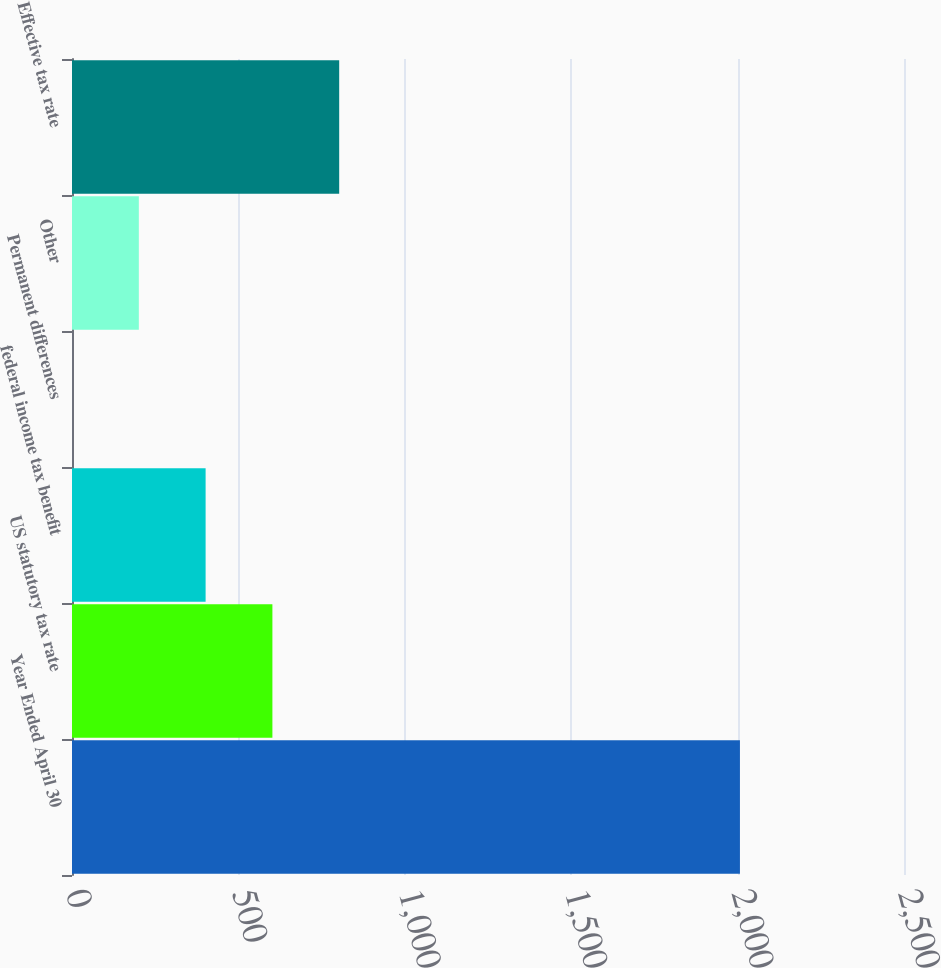Convert chart. <chart><loc_0><loc_0><loc_500><loc_500><bar_chart><fcel>Year Ended April 30<fcel>US statutory tax rate<fcel>federal income tax benefit<fcel>Permanent differences<fcel>Other<fcel>Effective tax rate<nl><fcel>2007<fcel>602.17<fcel>401.48<fcel>0.1<fcel>200.79<fcel>802.86<nl></chart> 